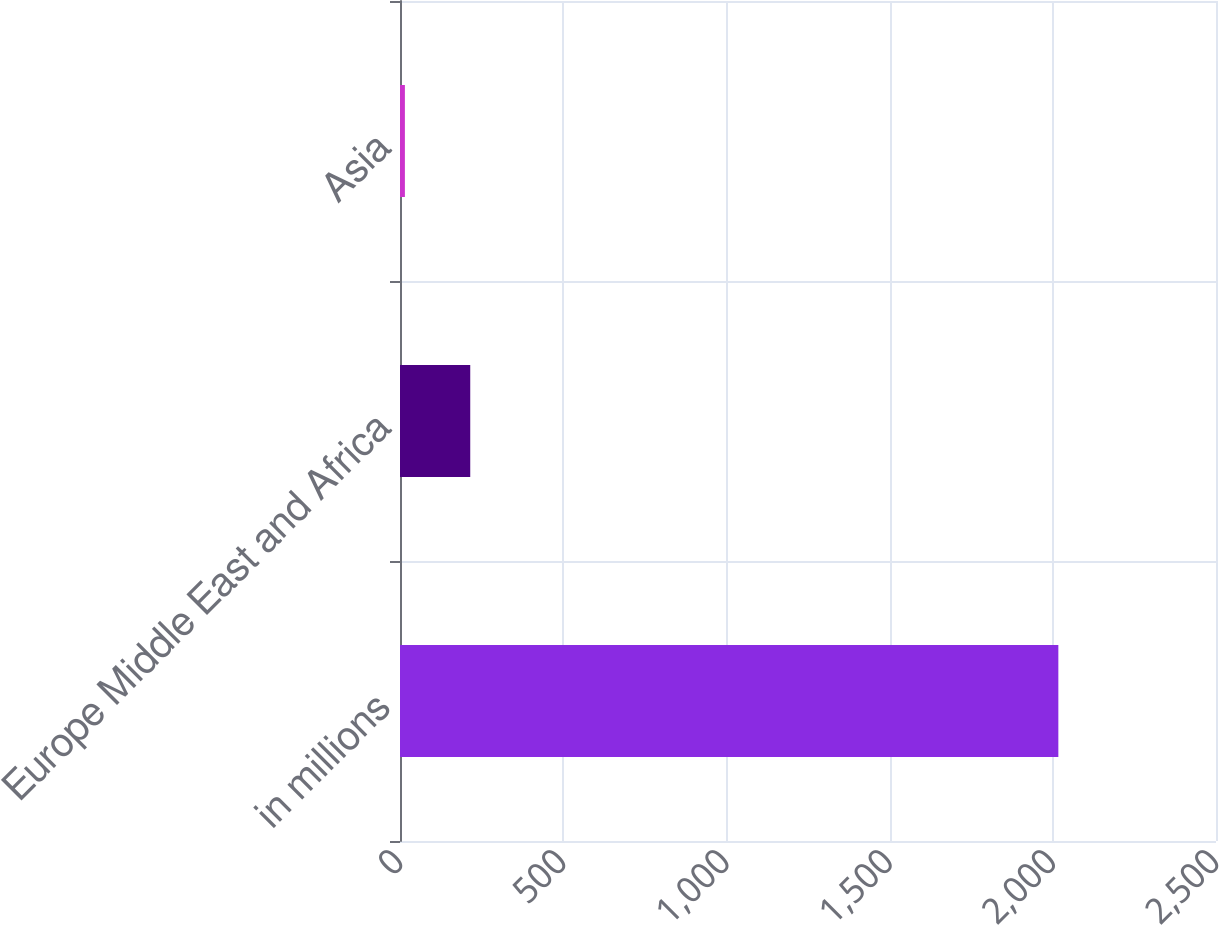Convert chart to OTSL. <chart><loc_0><loc_0><loc_500><loc_500><bar_chart><fcel>in millions<fcel>Europe Middle East and Africa<fcel>Asia<nl><fcel>2017<fcel>215.2<fcel>15<nl></chart> 